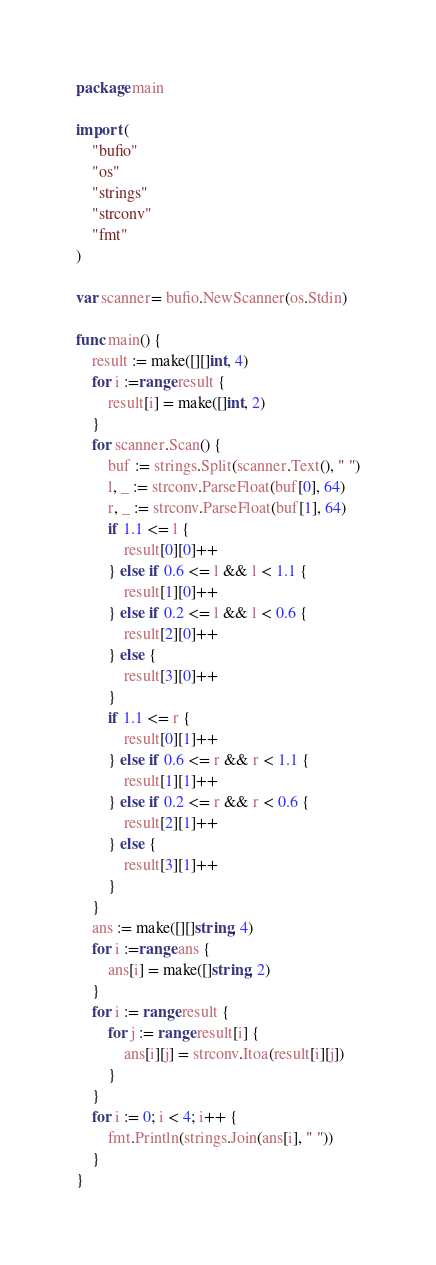Convert code to text. <code><loc_0><loc_0><loc_500><loc_500><_Go_>package main

import (
	"bufio"
	"os"
	"strings"
	"strconv"
	"fmt"
)

var scanner= bufio.NewScanner(os.Stdin)

func main() {
	result := make([][]int, 4)
	for i :=range result {
		result[i] = make([]int, 2)
	}
	for scanner.Scan() {
		buf := strings.Split(scanner.Text(), " ")
		l, _ := strconv.ParseFloat(buf[0], 64)
		r, _ := strconv.ParseFloat(buf[1], 64)
		if 1.1 <= l {
			result[0][0]++
		} else if 0.6 <= l && l < 1.1 {
			result[1][0]++
		} else if 0.2 <= l && l < 0.6 {
			result[2][0]++
		} else {
			result[3][0]++
		}
		if 1.1 <= r {
			result[0][1]++
		} else if 0.6 <= r && r < 1.1 {
			result[1][1]++
		} else if 0.2 <= r && r < 0.6 {
			result[2][1]++
		} else {
			result[3][1]++
		}
	}
	ans := make([][]string, 4)
	for i :=range ans {
		ans[i] = make([]string, 2)
	}
	for i := range result {
		for j := range result[i] {
			ans[i][j] = strconv.Itoa(result[i][j])
		}
	}
	for i := 0; i < 4; i++ {
		fmt.Println(strings.Join(ans[i], " "))
	}
}
</code> 